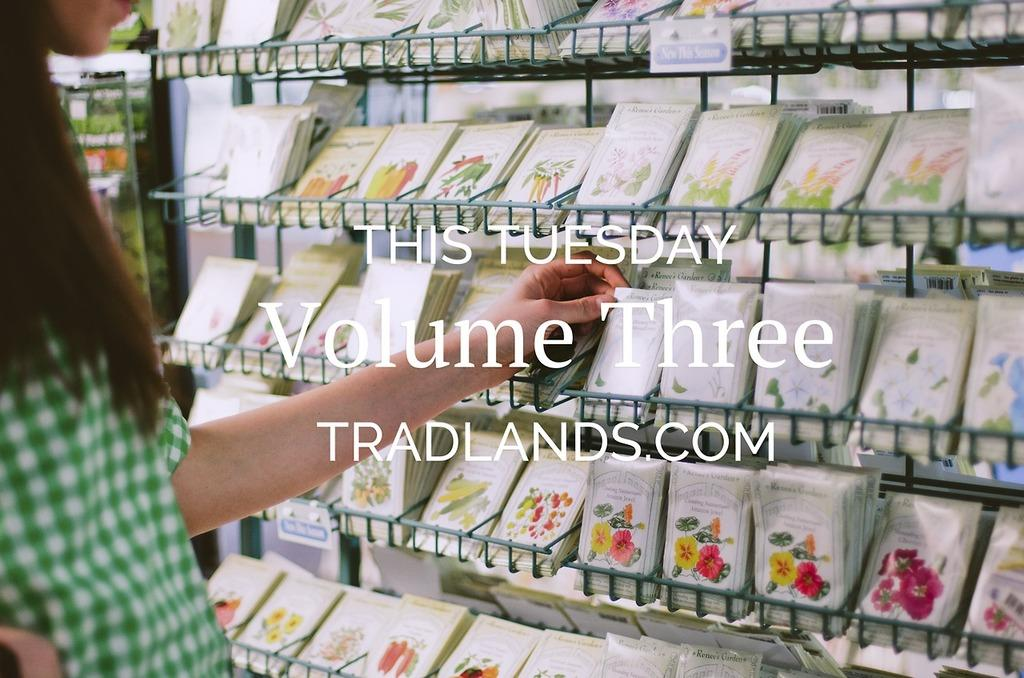<image>
Give a short and clear explanation of the subsequent image. a flyer that shows flower seed packs that says 'this tuesday volume three tradlands.com' 